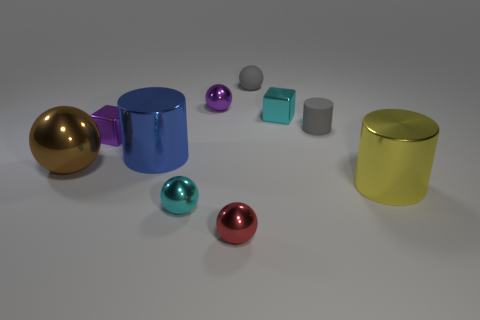Subtract all brown balls. How many balls are left? 4 Subtract all cylinders. How many objects are left? 7 Subtract all cyan cubes. How many cubes are left? 1 Subtract 2 blocks. How many blocks are left? 0 Subtract all cyan cubes. Subtract all green spheres. How many cubes are left? 1 Subtract all blue cubes. How many brown spheres are left? 1 Subtract all big blue cylinders. Subtract all gray matte cylinders. How many objects are left? 8 Add 8 cyan objects. How many cyan objects are left? 10 Add 4 tiny metal spheres. How many tiny metal spheres exist? 7 Subtract 0 brown cylinders. How many objects are left? 10 